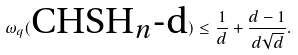Convert formula to latex. <formula><loc_0><loc_0><loc_500><loc_500>\omega _ { q } ( \text {CHSH$_{n}$-d} ) \leq \frac { 1 } { d } + \frac { d - 1 } { d \sqrt { d } } .</formula> 